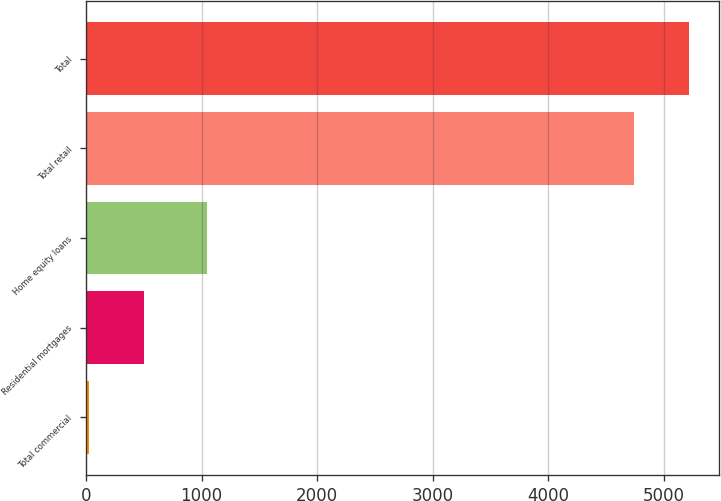Convert chart to OTSL. <chart><loc_0><loc_0><loc_500><loc_500><bar_chart><fcel>Total commercial<fcel>Residential mortgages<fcel>Home equity loans<fcel>Total retail<fcel>Total<nl><fcel>28<fcel>502.3<fcel>1046<fcel>4743<fcel>5217.3<nl></chart> 